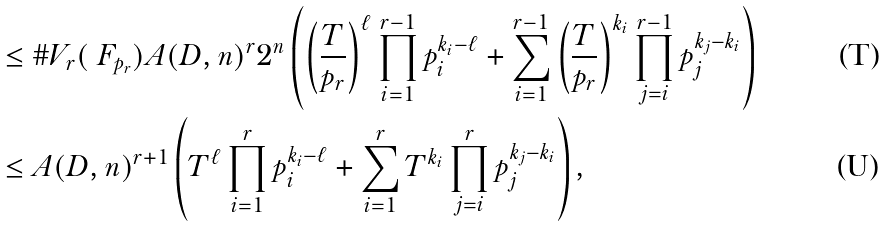<formula> <loc_0><loc_0><loc_500><loc_500>& \leq \# V _ { r } ( \ F _ { p _ { r } } ) A ( D , n ) ^ { r } 2 ^ { n } \left ( \left ( \frac { T } { p _ { r } } \right ) ^ { \ell } \prod _ { i = 1 } ^ { r - 1 } p _ { i } ^ { k _ { i } - \ell } + \sum _ { i = 1 } ^ { r - 1 } \left ( \frac { T } { p _ { r } } \right ) ^ { k _ { i } } \prod _ { j = i } ^ { r - 1 } p _ { j } ^ { k _ { j } - k _ { i } } \right ) \\ & \leq A ( D , n ) ^ { r + 1 } \left ( T ^ { \ell } \prod _ { i = 1 } ^ { r } p _ { i } ^ { k _ { i } - \ell } + \sum _ { i = 1 } ^ { r } T ^ { k _ { i } } \prod _ { j = i } ^ { r } p _ { j } ^ { k _ { j } - k _ { i } } \right ) ,</formula> 